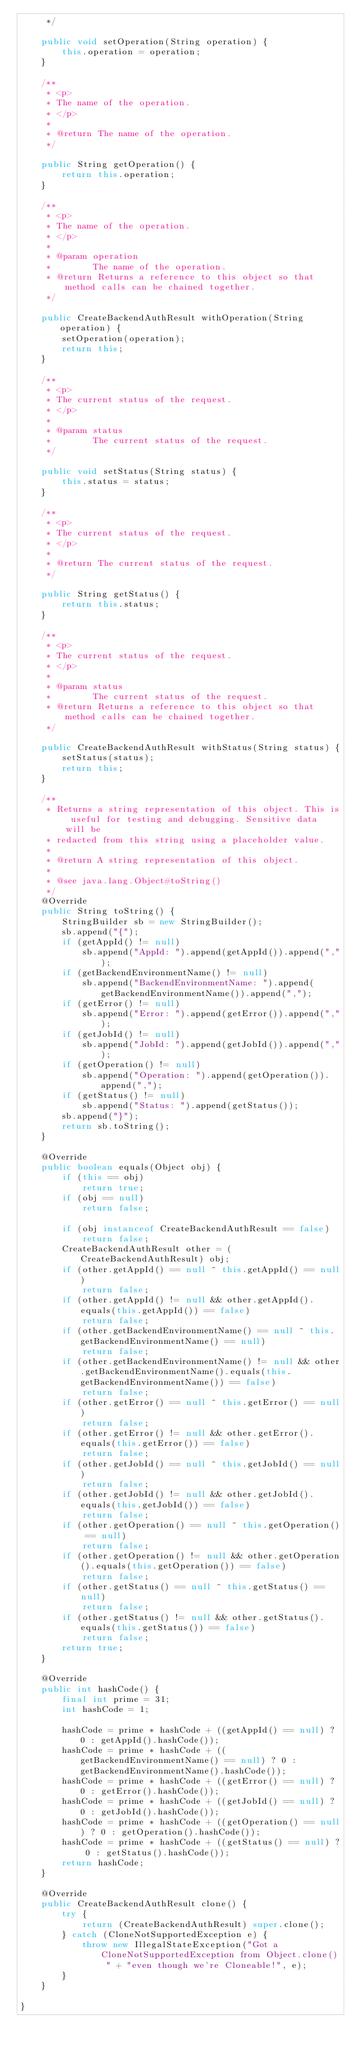<code> <loc_0><loc_0><loc_500><loc_500><_Java_>     */

    public void setOperation(String operation) {
        this.operation = operation;
    }

    /**
     * <p>
     * The name of the operation.
     * </p>
     * 
     * @return The name of the operation.
     */

    public String getOperation() {
        return this.operation;
    }

    /**
     * <p>
     * The name of the operation.
     * </p>
     * 
     * @param operation
     *        The name of the operation.
     * @return Returns a reference to this object so that method calls can be chained together.
     */

    public CreateBackendAuthResult withOperation(String operation) {
        setOperation(operation);
        return this;
    }

    /**
     * <p>
     * The current status of the request.
     * </p>
     * 
     * @param status
     *        The current status of the request.
     */

    public void setStatus(String status) {
        this.status = status;
    }

    /**
     * <p>
     * The current status of the request.
     * </p>
     * 
     * @return The current status of the request.
     */

    public String getStatus() {
        return this.status;
    }

    /**
     * <p>
     * The current status of the request.
     * </p>
     * 
     * @param status
     *        The current status of the request.
     * @return Returns a reference to this object so that method calls can be chained together.
     */

    public CreateBackendAuthResult withStatus(String status) {
        setStatus(status);
        return this;
    }

    /**
     * Returns a string representation of this object. This is useful for testing and debugging. Sensitive data will be
     * redacted from this string using a placeholder value.
     *
     * @return A string representation of this object.
     *
     * @see java.lang.Object#toString()
     */
    @Override
    public String toString() {
        StringBuilder sb = new StringBuilder();
        sb.append("{");
        if (getAppId() != null)
            sb.append("AppId: ").append(getAppId()).append(",");
        if (getBackendEnvironmentName() != null)
            sb.append("BackendEnvironmentName: ").append(getBackendEnvironmentName()).append(",");
        if (getError() != null)
            sb.append("Error: ").append(getError()).append(",");
        if (getJobId() != null)
            sb.append("JobId: ").append(getJobId()).append(",");
        if (getOperation() != null)
            sb.append("Operation: ").append(getOperation()).append(",");
        if (getStatus() != null)
            sb.append("Status: ").append(getStatus());
        sb.append("}");
        return sb.toString();
    }

    @Override
    public boolean equals(Object obj) {
        if (this == obj)
            return true;
        if (obj == null)
            return false;

        if (obj instanceof CreateBackendAuthResult == false)
            return false;
        CreateBackendAuthResult other = (CreateBackendAuthResult) obj;
        if (other.getAppId() == null ^ this.getAppId() == null)
            return false;
        if (other.getAppId() != null && other.getAppId().equals(this.getAppId()) == false)
            return false;
        if (other.getBackendEnvironmentName() == null ^ this.getBackendEnvironmentName() == null)
            return false;
        if (other.getBackendEnvironmentName() != null && other.getBackendEnvironmentName().equals(this.getBackendEnvironmentName()) == false)
            return false;
        if (other.getError() == null ^ this.getError() == null)
            return false;
        if (other.getError() != null && other.getError().equals(this.getError()) == false)
            return false;
        if (other.getJobId() == null ^ this.getJobId() == null)
            return false;
        if (other.getJobId() != null && other.getJobId().equals(this.getJobId()) == false)
            return false;
        if (other.getOperation() == null ^ this.getOperation() == null)
            return false;
        if (other.getOperation() != null && other.getOperation().equals(this.getOperation()) == false)
            return false;
        if (other.getStatus() == null ^ this.getStatus() == null)
            return false;
        if (other.getStatus() != null && other.getStatus().equals(this.getStatus()) == false)
            return false;
        return true;
    }

    @Override
    public int hashCode() {
        final int prime = 31;
        int hashCode = 1;

        hashCode = prime * hashCode + ((getAppId() == null) ? 0 : getAppId().hashCode());
        hashCode = prime * hashCode + ((getBackendEnvironmentName() == null) ? 0 : getBackendEnvironmentName().hashCode());
        hashCode = prime * hashCode + ((getError() == null) ? 0 : getError().hashCode());
        hashCode = prime * hashCode + ((getJobId() == null) ? 0 : getJobId().hashCode());
        hashCode = prime * hashCode + ((getOperation() == null) ? 0 : getOperation().hashCode());
        hashCode = prime * hashCode + ((getStatus() == null) ? 0 : getStatus().hashCode());
        return hashCode;
    }

    @Override
    public CreateBackendAuthResult clone() {
        try {
            return (CreateBackendAuthResult) super.clone();
        } catch (CloneNotSupportedException e) {
            throw new IllegalStateException("Got a CloneNotSupportedException from Object.clone() " + "even though we're Cloneable!", e);
        }
    }

}
</code> 